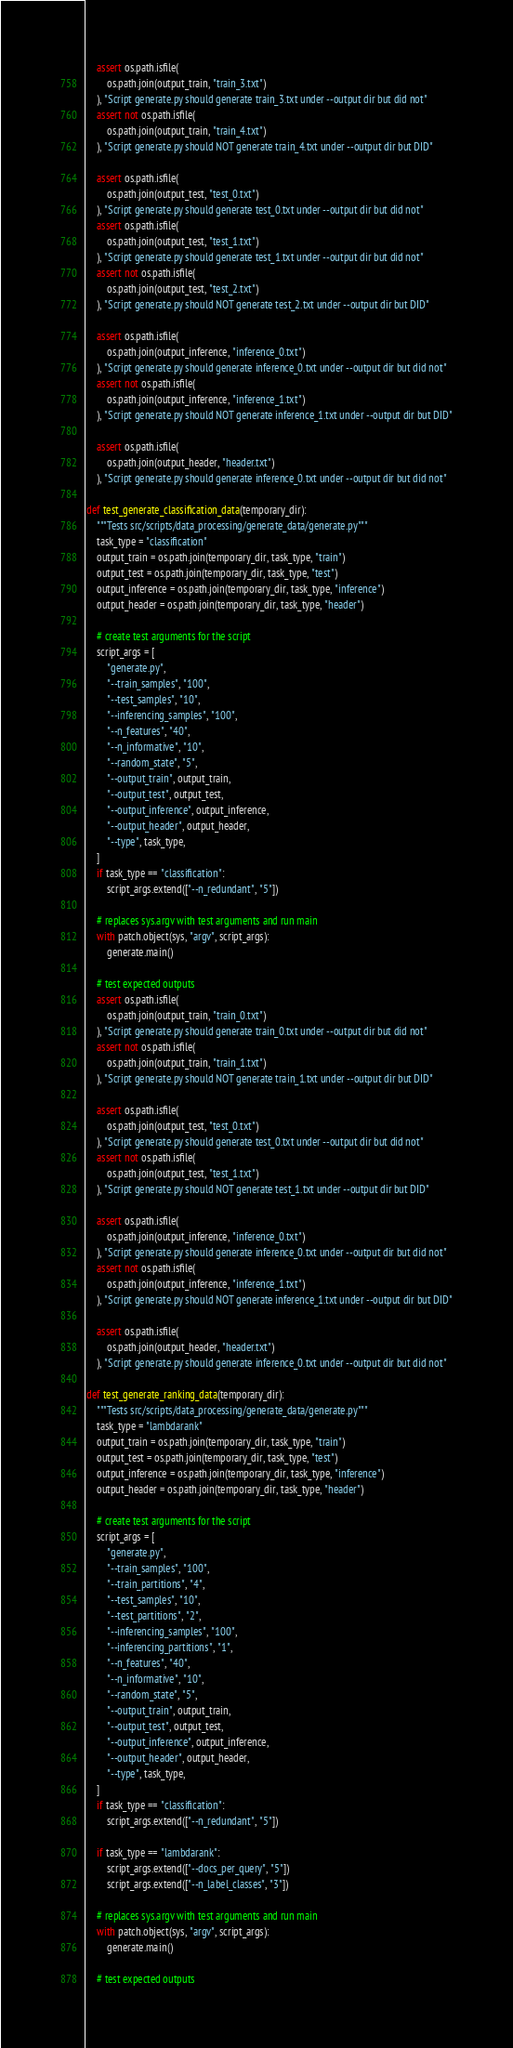Convert code to text. <code><loc_0><loc_0><loc_500><loc_500><_Python_>    assert os.path.isfile(
        os.path.join(output_train, "train_3.txt")
    ), "Script generate.py should generate train_3.txt under --output dir but did not"
    assert not os.path.isfile(
        os.path.join(output_train, "train_4.txt")
    ), "Script generate.py should NOT generate train_4.txt under --output dir but DID"

    assert os.path.isfile(
        os.path.join(output_test, "test_0.txt")
    ), "Script generate.py should generate test_0.txt under --output dir but did not"
    assert os.path.isfile(
        os.path.join(output_test, "test_1.txt")
    ), "Script generate.py should generate test_1.txt under --output dir but did not"
    assert not os.path.isfile(
        os.path.join(output_test, "test_2.txt")
    ), "Script generate.py should NOT generate test_2.txt under --output dir but DID"

    assert os.path.isfile(
        os.path.join(output_inference, "inference_0.txt")
    ), "Script generate.py should generate inference_0.txt under --output dir but did not"
    assert not os.path.isfile(
        os.path.join(output_inference, "inference_1.txt")
    ), "Script generate.py should NOT generate inference_1.txt under --output dir but DID"

    assert os.path.isfile(
        os.path.join(output_header, "header.txt")
    ), "Script generate.py should generate inference_0.txt under --output dir but did not"

def test_generate_classification_data(temporary_dir):
    """Tests src/scripts/data_processing/generate_data/generate.py"""
    task_type = "classification"
    output_train = os.path.join(temporary_dir, task_type, "train")
    output_test = os.path.join(temporary_dir, task_type, "test")
    output_inference = os.path.join(temporary_dir, task_type, "inference")
    output_header = os.path.join(temporary_dir, task_type, "header")

    # create test arguments for the script
    script_args = [
        "generate.py",
        "--train_samples", "100",
        "--test_samples", "10",
        "--inferencing_samples", "100",
        "--n_features", "40",
        "--n_informative", "10",
        "--random_state", "5",
        "--output_train", output_train,
        "--output_test", output_test,
        "--output_inference", output_inference,
        "--output_header", output_header,
        "--type", task_type,
    ]
    if task_type == "classification":
        script_args.extend(["--n_redundant", "5"])

    # replaces sys.argv with test arguments and run main
    with patch.object(sys, "argv", script_args):
        generate.main()

    # test expected outputs
    assert os.path.isfile(
        os.path.join(output_train, "train_0.txt")
    ), "Script generate.py should generate train_0.txt under --output dir but did not"
    assert not os.path.isfile(
        os.path.join(output_train, "train_1.txt")
    ), "Script generate.py should NOT generate train_1.txt under --output dir but DID"

    assert os.path.isfile(
        os.path.join(output_test, "test_0.txt")
    ), "Script generate.py should generate test_0.txt under --output dir but did not"
    assert not os.path.isfile(
        os.path.join(output_test, "test_1.txt")
    ), "Script generate.py should NOT generate test_1.txt under --output dir but DID"

    assert os.path.isfile(
        os.path.join(output_inference, "inference_0.txt")
    ), "Script generate.py should generate inference_0.txt under --output dir but did not"
    assert not os.path.isfile(
        os.path.join(output_inference, "inference_1.txt")
    ), "Script generate.py should NOT generate inference_1.txt under --output dir but DID"

    assert os.path.isfile(
        os.path.join(output_header, "header.txt")
    ), "Script generate.py should generate inference_0.txt under --output dir but did not"

def test_generate_ranking_data(temporary_dir):
    """Tests src/scripts/data_processing/generate_data/generate.py"""
    task_type = "lambdarank"
    output_train = os.path.join(temporary_dir, task_type, "train")
    output_test = os.path.join(temporary_dir, task_type, "test")
    output_inference = os.path.join(temporary_dir, task_type, "inference")
    output_header = os.path.join(temporary_dir, task_type, "header")

    # create test arguments for the script
    script_args = [
        "generate.py",
        "--train_samples", "100",
        "--train_partitions", "4",
        "--test_samples", "10",
        "--test_partitions", "2",
        "--inferencing_samples", "100",
        "--inferencing_partitions", "1",
        "--n_features", "40",
        "--n_informative", "10",
        "--random_state", "5",
        "--output_train", output_train,
        "--output_test", output_test,
        "--output_inference", output_inference,
        "--output_header", output_header,
        "--type", task_type,
    ]
    if task_type == "classification":
        script_args.extend(["--n_redundant", "5"])

    if task_type == "lambdarank":
        script_args.extend(["--docs_per_query", "5"])
        script_args.extend(["--n_label_classes", "3"])

    # replaces sys.argv with test arguments and run main
    with patch.object(sys, "argv", script_args):
        generate.main()

    # test expected outputs</code> 